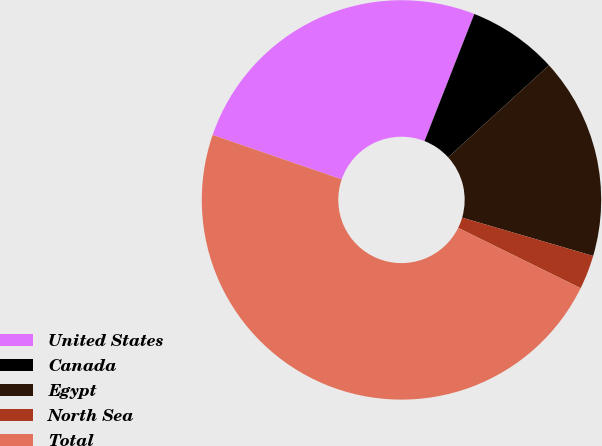Convert chart. <chart><loc_0><loc_0><loc_500><loc_500><pie_chart><fcel>United States<fcel>Canada<fcel>Egypt<fcel>North Sea<fcel>Total<nl><fcel>25.67%<fcel>7.28%<fcel>16.3%<fcel>2.76%<fcel>47.98%<nl></chart> 